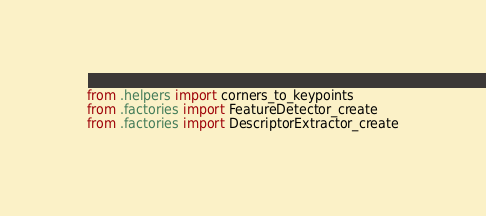<code> <loc_0><loc_0><loc_500><loc_500><_Python_>from .helpers import corners_to_keypoints
from .factories import FeatureDetector_create
from .factories import DescriptorExtractor_create
</code> 